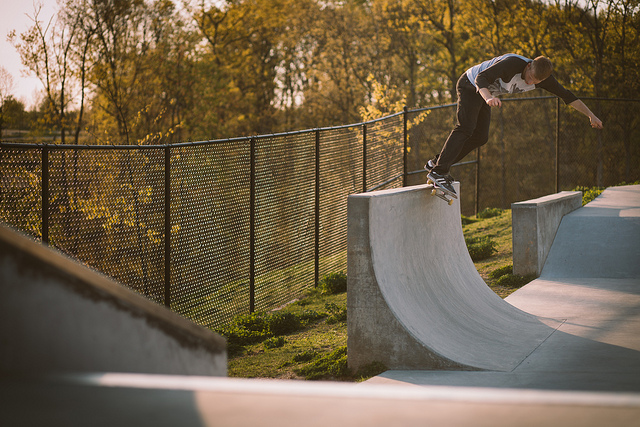Can you describe the setting of the skate park? The skate park is outdoors with a ramp and surrounding fence, and there are trees indicating that it's probably in a park or a similarly natural environment. Does the skate park look busy? No, the skate park doesn't look busy. The image shows a single individual skateboarding, with no evidence of other people around. 